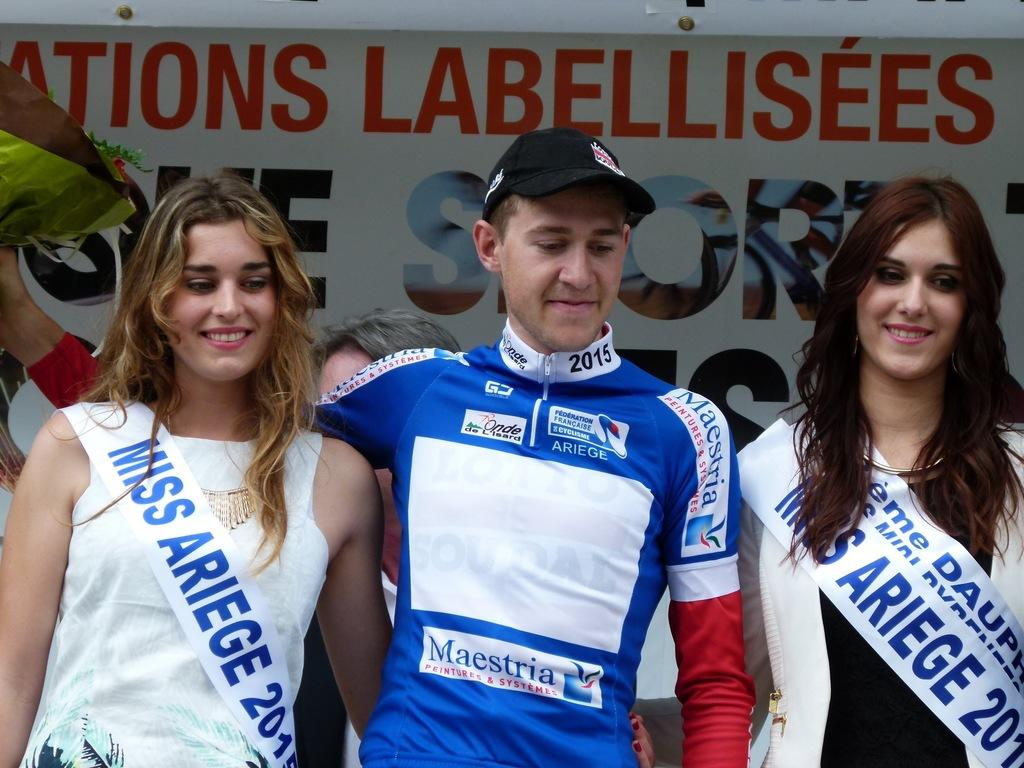<image>
Render a clear and concise summary of the photo. A man is posed in between two women who are wearing Miss Ariege sashes. 